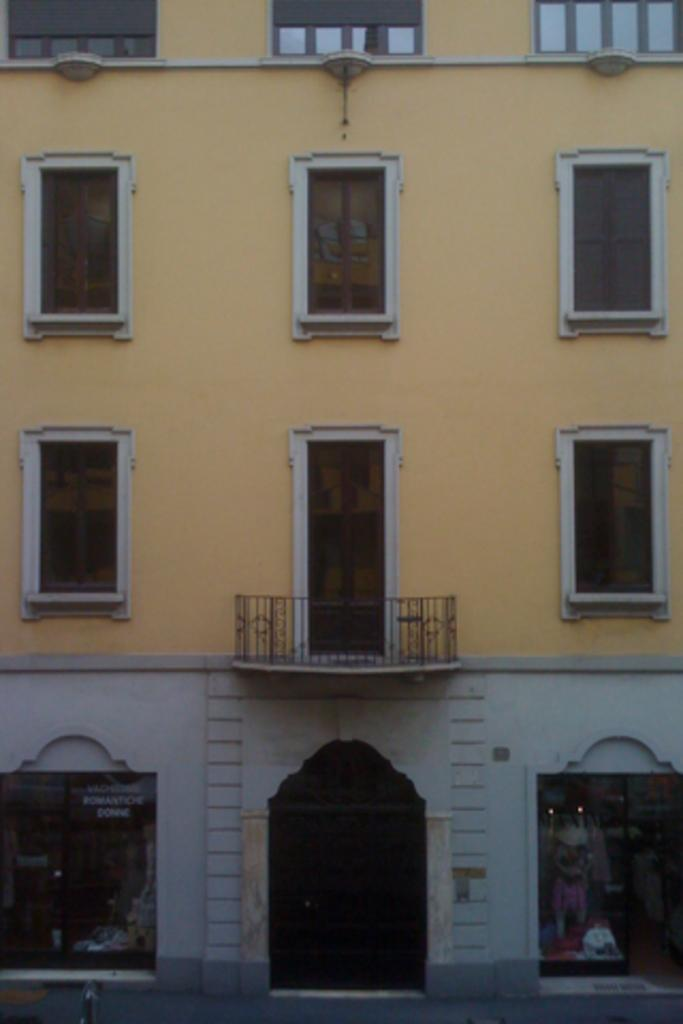What type of structure is visible in the image? There is a building in the image. What features can be seen on the building? The building has windows and doors. What else is present in the image besides the building? There is a board and shops visible in the image. Can you determine the time of day the image was taken? The image was likely taken during the day, as there is no indication of darkness or artificial lighting. What type of pear is being used to create harmony in the image? There is no pear or any indication of harmony present in the image. 